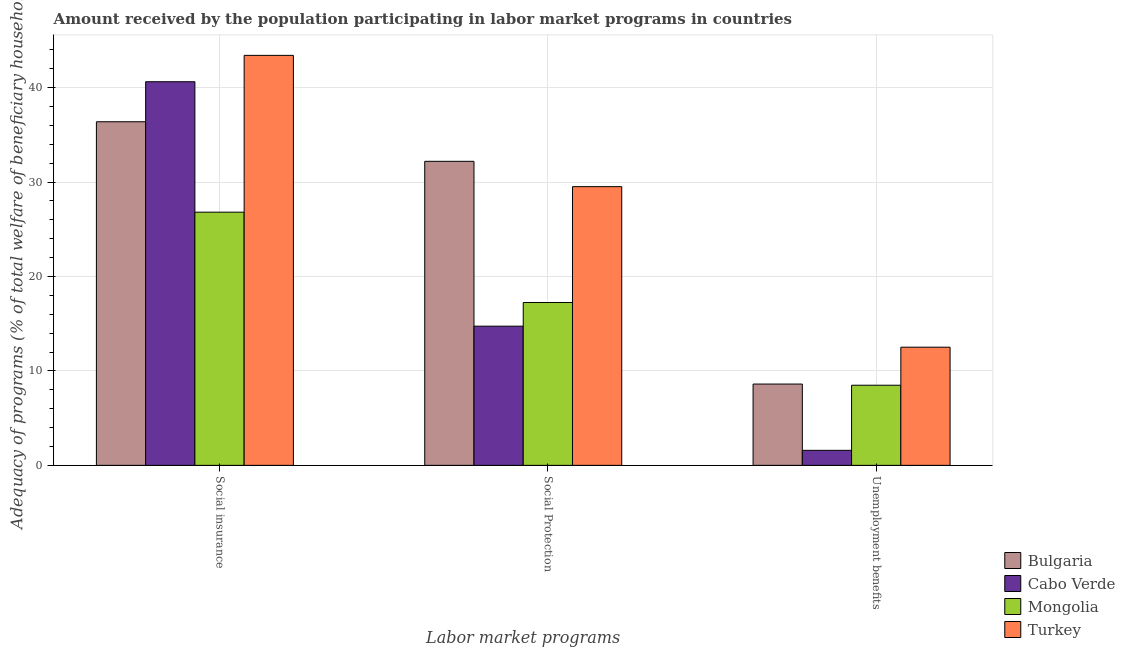How many different coloured bars are there?
Offer a terse response. 4. How many bars are there on the 1st tick from the right?
Provide a short and direct response. 4. What is the label of the 3rd group of bars from the left?
Provide a short and direct response. Unemployment benefits. What is the amount received by the population participating in unemployment benefits programs in Cabo Verde?
Keep it short and to the point. 1.59. Across all countries, what is the maximum amount received by the population participating in social insurance programs?
Provide a succinct answer. 43.41. Across all countries, what is the minimum amount received by the population participating in social protection programs?
Your answer should be very brief. 14.74. In which country was the amount received by the population participating in social insurance programs maximum?
Ensure brevity in your answer.  Turkey. In which country was the amount received by the population participating in unemployment benefits programs minimum?
Ensure brevity in your answer.  Cabo Verde. What is the total amount received by the population participating in social protection programs in the graph?
Your answer should be compact. 93.69. What is the difference between the amount received by the population participating in unemployment benefits programs in Cabo Verde and that in Mongolia?
Your answer should be compact. -6.9. What is the difference between the amount received by the population participating in unemployment benefits programs in Turkey and the amount received by the population participating in social protection programs in Bulgaria?
Offer a terse response. -19.68. What is the average amount received by the population participating in social insurance programs per country?
Your response must be concise. 36.81. What is the difference between the amount received by the population participating in unemployment benefits programs and amount received by the population participating in social protection programs in Mongolia?
Ensure brevity in your answer.  -8.76. In how many countries, is the amount received by the population participating in unemployment benefits programs greater than 16 %?
Your answer should be very brief. 0. What is the ratio of the amount received by the population participating in social insurance programs in Mongolia to that in Turkey?
Your answer should be compact. 0.62. Is the amount received by the population participating in unemployment benefits programs in Mongolia less than that in Bulgaria?
Provide a short and direct response. Yes. What is the difference between the highest and the second highest amount received by the population participating in social insurance programs?
Offer a very short reply. 2.79. What is the difference between the highest and the lowest amount received by the population participating in social insurance programs?
Keep it short and to the point. 16.6. Is it the case that in every country, the sum of the amount received by the population participating in social insurance programs and amount received by the population participating in social protection programs is greater than the amount received by the population participating in unemployment benefits programs?
Make the answer very short. Yes. What is the title of the graph?
Your answer should be compact. Amount received by the population participating in labor market programs in countries. What is the label or title of the X-axis?
Your response must be concise. Labor market programs. What is the label or title of the Y-axis?
Provide a succinct answer. Adequacy of programs (% of total welfare of beneficiary households). What is the Adequacy of programs (% of total welfare of beneficiary households) in Bulgaria in Social insurance?
Offer a very short reply. 36.38. What is the Adequacy of programs (% of total welfare of beneficiary households) of Cabo Verde in Social insurance?
Your response must be concise. 40.62. What is the Adequacy of programs (% of total welfare of beneficiary households) in Mongolia in Social insurance?
Ensure brevity in your answer.  26.81. What is the Adequacy of programs (% of total welfare of beneficiary households) of Turkey in Social insurance?
Your response must be concise. 43.41. What is the Adequacy of programs (% of total welfare of beneficiary households) in Bulgaria in Social Protection?
Keep it short and to the point. 32.19. What is the Adequacy of programs (% of total welfare of beneficiary households) of Cabo Verde in Social Protection?
Offer a very short reply. 14.74. What is the Adequacy of programs (% of total welfare of beneficiary households) in Mongolia in Social Protection?
Provide a succinct answer. 17.25. What is the Adequacy of programs (% of total welfare of beneficiary households) in Turkey in Social Protection?
Ensure brevity in your answer.  29.51. What is the Adequacy of programs (% of total welfare of beneficiary households) in Bulgaria in Unemployment benefits?
Keep it short and to the point. 8.61. What is the Adequacy of programs (% of total welfare of beneficiary households) of Cabo Verde in Unemployment benefits?
Provide a short and direct response. 1.59. What is the Adequacy of programs (% of total welfare of beneficiary households) of Mongolia in Unemployment benefits?
Provide a succinct answer. 8.48. What is the Adequacy of programs (% of total welfare of beneficiary households) in Turkey in Unemployment benefits?
Provide a short and direct response. 12.51. Across all Labor market programs, what is the maximum Adequacy of programs (% of total welfare of beneficiary households) in Bulgaria?
Give a very brief answer. 36.38. Across all Labor market programs, what is the maximum Adequacy of programs (% of total welfare of beneficiary households) in Cabo Verde?
Keep it short and to the point. 40.62. Across all Labor market programs, what is the maximum Adequacy of programs (% of total welfare of beneficiary households) in Mongolia?
Your answer should be compact. 26.81. Across all Labor market programs, what is the maximum Adequacy of programs (% of total welfare of beneficiary households) of Turkey?
Make the answer very short. 43.41. Across all Labor market programs, what is the minimum Adequacy of programs (% of total welfare of beneficiary households) of Bulgaria?
Your answer should be very brief. 8.61. Across all Labor market programs, what is the minimum Adequacy of programs (% of total welfare of beneficiary households) of Cabo Verde?
Offer a terse response. 1.59. Across all Labor market programs, what is the minimum Adequacy of programs (% of total welfare of beneficiary households) of Mongolia?
Your answer should be very brief. 8.48. Across all Labor market programs, what is the minimum Adequacy of programs (% of total welfare of beneficiary households) of Turkey?
Your answer should be very brief. 12.51. What is the total Adequacy of programs (% of total welfare of beneficiary households) in Bulgaria in the graph?
Keep it short and to the point. 77.18. What is the total Adequacy of programs (% of total welfare of beneficiary households) in Cabo Verde in the graph?
Provide a succinct answer. 56.95. What is the total Adequacy of programs (% of total welfare of beneficiary households) of Mongolia in the graph?
Provide a succinct answer. 52.54. What is the total Adequacy of programs (% of total welfare of beneficiary households) of Turkey in the graph?
Your response must be concise. 85.43. What is the difference between the Adequacy of programs (% of total welfare of beneficiary households) of Bulgaria in Social insurance and that in Social Protection?
Provide a short and direct response. 4.19. What is the difference between the Adequacy of programs (% of total welfare of beneficiary households) of Cabo Verde in Social insurance and that in Social Protection?
Keep it short and to the point. 25.88. What is the difference between the Adequacy of programs (% of total welfare of beneficiary households) of Mongolia in Social insurance and that in Social Protection?
Provide a succinct answer. 9.56. What is the difference between the Adequacy of programs (% of total welfare of beneficiary households) of Turkey in Social insurance and that in Social Protection?
Ensure brevity in your answer.  13.9. What is the difference between the Adequacy of programs (% of total welfare of beneficiary households) in Bulgaria in Social insurance and that in Unemployment benefits?
Offer a very short reply. 27.77. What is the difference between the Adequacy of programs (% of total welfare of beneficiary households) of Cabo Verde in Social insurance and that in Unemployment benefits?
Offer a terse response. 39.03. What is the difference between the Adequacy of programs (% of total welfare of beneficiary households) of Mongolia in Social insurance and that in Unemployment benefits?
Give a very brief answer. 18.32. What is the difference between the Adequacy of programs (% of total welfare of beneficiary households) of Turkey in Social insurance and that in Unemployment benefits?
Offer a very short reply. 30.9. What is the difference between the Adequacy of programs (% of total welfare of beneficiary households) of Bulgaria in Social Protection and that in Unemployment benefits?
Your answer should be very brief. 23.58. What is the difference between the Adequacy of programs (% of total welfare of beneficiary households) in Cabo Verde in Social Protection and that in Unemployment benefits?
Your answer should be very brief. 13.15. What is the difference between the Adequacy of programs (% of total welfare of beneficiary households) in Mongolia in Social Protection and that in Unemployment benefits?
Keep it short and to the point. 8.76. What is the difference between the Adequacy of programs (% of total welfare of beneficiary households) of Turkey in Social Protection and that in Unemployment benefits?
Make the answer very short. 17. What is the difference between the Adequacy of programs (% of total welfare of beneficiary households) of Bulgaria in Social insurance and the Adequacy of programs (% of total welfare of beneficiary households) of Cabo Verde in Social Protection?
Ensure brevity in your answer.  21.64. What is the difference between the Adequacy of programs (% of total welfare of beneficiary households) of Bulgaria in Social insurance and the Adequacy of programs (% of total welfare of beneficiary households) of Mongolia in Social Protection?
Make the answer very short. 19.14. What is the difference between the Adequacy of programs (% of total welfare of beneficiary households) of Bulgaria in Social insurance and the Adequacy of programs (% of total welfare of beneficiary households) of Turkey in Social Protection?
Provide a short and direct response. 6.87. What is the difference between the Adequacy of programs (% of total welfare of beneficiary households) of Cabo Verde in Social insurance and the Adequacy of programs (% of total welfare of beneficiary households) of Mongolia in Social Protection?
Provide a short and direct response. 23.38. What is the difference between the Adequacy of programs (% of total welfare of beneficiary households) of Cabo Verde in Social insurance and the Adequacy of programs (% of total welfare of beneficiary households) of Turkey in Social Protection?
Offer a terse response. 11.11. What is the difference between the Adequacy of programs (% of total welfare of beneficiary households) in Mongolia in Social insurance and the Adequacy of programs (% of total welfare of beneficiary households) in Turkey in Social Protection?
Provide a succinct answer. -2.7. What is the difference between the Adequacy of programs (% of total welfare of beneficiary households) in Bulgaria in Social insurance and the Adequacy of programs (% of total welfare of beneficiary households) in Cabo Verde in Unemployment benefits?
Keep it short and to the point. 34.79. What is the difference between the Adequacy of programs (% of total welfare of beneficiary households) of Bulgaria in Social insurance and the Adequacy of programs (% of total welfare of beneficiary households) of Mongolia in Unemployment benefits?
Your answer should be very brief. 27.9. What is the difference between the Adequacy of programs (% of total welfare of beneficiary households) in Bulgaria in Social insurance and the Adequacy of programs (% of total welfare of beneficiary households) in Turkey in Unemployment benefits?
Your answer should be very brief. 23.87. What is the difference between the Adequacy of programs (% of total welfare of beneficiary households) in Cabo Verde in Social insurance and the Adequacy of programs (% of total welfare of beneficiary households) in Mongolia in Unemployment benefits?
Provide a succinct answer. 32.14. What is the difference between the Adequacy of programs (% of total welfare of beneficiary households) of Cabo Verde in Social insurance and the Adequacy of programs (% of total welfare of beneficiary households) of Turkey in Unemployment benefits?
Provide a succinct answer. 28.11. What is the difference between the Adequacy of programs (% of total welfare of beneficiary households) in Mongolia in Social insurance and the Adequacy of programs (% of total welfare of beneficiary households) in Turkey in Unemployment benefits?
Provide a succinct answer. 14.3. What is the difference between the Adequacy of programs (% of total welfare of beneficiary households) of Bulgaria in Social Protection and the Adequacy of programs (% of total welfare of beneficiary households) of Cabo Verde in Unemployment benefits?
Your answer should be very brief. 30.6. What is the difference between the Adequacy of programs (% of total welfare of beneficiary households) of Bulgaria in Social Protection and the Adequacy of programs (% of total welfare of beneficiary households) of Mongolia in Unemployment benefits?
Make the answer very short. 23.71. What is the difference between the Adequacy of programs (% of total welfare of beneficiary households) of Bulgaria in Social Protection and the Adequacy of programs (% of total welfare of beneficiary households) of Turkey in Unemployment benefits?
Keep it short and to the point. 19.68. What is the difference between the Adequacy of programs (% of total welfare of beneficiary households) in Cabo Verde in Social Protection and the Adequacy of programs (% of total welfare of beneficiary households) in Mongolia in Unemployment benefits?
Provide a short and direct response. 6.25. What is the difference between the Adequacy of programs (% of total welfare of beneficiary households) of Cabo Verde in Social Protection and the Adequacy of programs (% of total welfare of beneficiary households) of Turkey in Unemployment benefits?
Make the answer very short. 2.23. What is the difference between the Adequacy of programs (% of total welfare of beneficiary households) of Mongolia in Social Protection and the Adequacy of programs (% of total welfare of beneficiary households) of Turkey in Unemployment benefits?
Your answer should be very brief. 4.73. What is the average Adequacy of programs (% of total welfare of beneficiary households) in Bulgaria per Labor market programs?
Provide a short and direct response. 25.73. What is the average Adequacy of programs (% of total welfare of beneficiary households) of Cabo Verde per Labor market programs?
Ensure brevity in your answer.  18.98. What is the average Adequacy of programs (% of total welfare of beneficiary households) in Mongolia per Labor market programs?
Your answer should be very brief. 17.51. What is the average Adequacy of programs (% of total welfare of beneficiary households) of Turkey per Labor market programs?
Provide a short and direct response. 28.48. What is the difference between the Adequacy of programs (% of total welfare of beneficiary households) in Bulgaria and Adequacy of programs (% of total welfare of beneficiary households) in Cabo Verde in Social insurance?
Your response must be concise. -4.24. What is the difference between the Adequacy of programs (% of total welfare of beneficiary households) in Bulgaria and Adequacy of programs (% of total welfare of beneficiary households) in Mongolia in Social insurance?
Provide a short and direct response. 9.57. What is the difference between the Adequacy of programs (% of total welfare of beneficiary households) of Bulgaria and Adequacy of programs (% of total welfare of beneficiary households) of Turkey in Social insurance?
Your answer should be compact. -7.03. What is the difference between the Adequacy of programs (% of total welfare of beneficiary households) of Cabo Verde and Adequacy of programs (% of total welfare of beneficiary households) of Mongolia in Social insurance?
Give a very brief answer. 13.81. What is the difference between the Adequacy of programs (% of total welfare of beneficiary households) of Cabo Verde and Adequacy of programs (% of total welfare of beneficiary households) of Turkey in Social insurance?
Your response must be concise. -2.79. What is the difference between the Adequacy of programs (% of total welfare of beneficiary households) of Mongolia and Adequacy of programs (% of total welfare of beneficiary households) of Turkey in Social insurance?
Give a very brief answer. -16.6. What is the difference between the Adequacy of programs (% of total welfare of beneficiary households) in Bulgaria and Adequacy of programs (% of total welfare of beneficiary households) in Cabo Verde in Social Protection?
Ensure brevity in your answer.  17.45. What is the difference between the Adequacy of programs (% of total welfare of beneficiary households) of Bulgaria and Adequacy of programs (% of total welfare of beneficiary households) of Mongolia in Social Protection?
Your response must be concise. 14.95. What is the difference between the Adequacy of programs (% of total welfare of beneficiary households) of Bulgaria and Adequacy of programs (% of total welfare of beneficiary households) of Turkey in Social Protection?
Make the answer very short. 2.68. What is the difference between the Adequacy of programs (% of total welfare of beneficiary households) in Cabo Verde and Adequacy of programs (% of total welfare of beneficiary households) in Mongolia in Social Protection?
Your answer should be compact. -2.51. What is the difference between the Adequacy of programs (% of total welfare of beneficiary households) of Cabo Verde and Adequacy of programs (% of total welfare of beneficiary households) of Turkey in Social Protection?
Keep it short and to the point. -14.77. What is the difference between the Adequacy of programs (% of total welfare of beneficiary households) of Mongolia and Adequacy of programs (% of total welfare of beneficiary households) of Turkey in Social Protection?
Your answer should be very brief. -12.27. What is the difference between the Adequacy of programs (% of total welfare of beneficiary households) in Bulgaria and Adequacy of programs (% of total welfare of beneficiary households) in Cabo Verde in Unemployment benefits?
Provide a succinct answer. 7.02. What is the difference between the Adequacy of programs (% of total welfare of beneficiary households) of Bulgaria and Adequacy of programs (% of total welfare of beneficiary households) of Mongolia in Unemployment benefits?
Give a very brief answer. 0.12. What is the difference between the Adequacy of programs (% of total welfare of beneficiary households) of Bulgaria and Adequacy of programs (% of total welfare of beneficiary households) of Turkey in Unemployment benefits?
Your answer should be compact. -3.9. What is the difference between the Adequacy of programs (% of total welfare of beneficiary households) of Cabo Verde and Adequacy of programs (% of total welfare of beneficiary households) of Mongolia in Unemployment benefits?
Provide a short and direct response. -6.89. What is the difference between the Adequacy of programs (% of total welfare of beneficiary households) in Cabo Verde and Adequacy of programs (% of total welfare of beneficiary households) in Turkey in Unemployment benefits?
Your answer should be compact. -10.92. What is the difference between the Adequacy of programs (% of total welfare of beneficiary households) of Mongolia and Adequacy of programs (% of total welfare of beneficiary households) of Turkey in Unemployment benefits?
Make the answer very short. -4.03. What is the ratio of the Adequacy of programs (% of total welfare of beneficiary households) in Bulgaria in Social insurance to that in Social Protection?
Your response must be concise. 1.13. What is the ratio of the Adequacy of programs (% of total welfare of beneficiary households) of Cabo Verde in Social insurance to that in Social Protection?
Offer a very short reply. 2.76. What is the ratio of the Adequacy of programs (% of total welfare of beneficiary households) in Mongolia in Social insurance to that in Social Protection?
Make the answer very short. 1.55. What is the ratio of the Adequacy of programs (% of total welfare of beneficiary households) of Turkey in Social insurance to that in Social Protection?
Your response must be concise. 1.47. What is the ratio of the Adequacy of programs (% of total welfare of beneficiary households) of Bulgaria in Social insurance to that in Unemployment benefits?
Make the answer very short. 4.23. What is the ratio of the Adequacy of programs (% of total welfare of beneficiary households) of Cabo Verde in Social insurance to that in Unemployment benefits?
Ensure brevity in your answer.  25.56. What is the ratio of the Adequacy of programs (% of total welfare of beneficiary households) in Mongolia in Social insurance to that in Unemployment benefits?
Make the answer very short. 3.16. What is the ratio of the Adequacy of programs (% of total welfare of beneficiary households) in Turkey in Social insurance to that in Unemployment benefits?
Provide a succinct answer. 3.47. What is the ratio of the Adequacy of programs (% of total welfare of beneficiary households) in Bulgaria in Social Protection to that in Unemployment benefits?
Your response must be concise. 3.74. What is the ratio of the Adequacy of programs (% of total welfare of beneficiary households) of Cabo Verde in Social Protection to that in Unemployment benefits?
Keep it short and to the point. 9.27. What is the ratio of the Adequacy of programs (% of total welfare of beneficiary households) in Mongolia in Social Protection to that in Unemployment benefits?
Make the answer very short. 2.03. What is the ratio of the Adequacy of programs (% of total welfare of beneficiary households) in Turkey in Social Protection to that in Unemployment benefits?
Keep it short and to the point. 2.36. What is the difference between the highest and the second highest Adequacy of programs (% of total welfare of beneficiary households) in Bulgaria?
Make the answer very short. 4.19. What is the difference between the highest and the second highest Adequacy of programs (% of total welfare of beneficiary households) in Cabo Verde?
Give a very brief answer. 25.88. What is the difference between the highest and the second highest Adequacy of programs (% of total welfare of beneficiary households) of Mongolia?
Your answer should be compact. 9.56. What is the difference between the highest and the second highest Adequacy of programs (% of total welfare of beneficiary households) in Turkey?
Your response must be concise. 13.9. What is the difference between the highest and the lowest Adequacy of programs (% of total welfare of beneficiary households) in Bulgaria?
Offer a terse response. 27.77. What is the difference between the highest and the lowest Adequacy of programs (% of total welfare of beneficiary households) in Cabo Verde?
Keep it short and to the point. 39.03. What is the difference between the highest and the lowest Adequacy of programs (% of total welfare of beneficiary households) of Mongolia?
Give a very brief answer. 18.32. What is the difference between the highest and the lowest Adequacy of programs (% of total welfare of beneficiary households) in Turkey?
Provide a short and direct response. 30.9. 